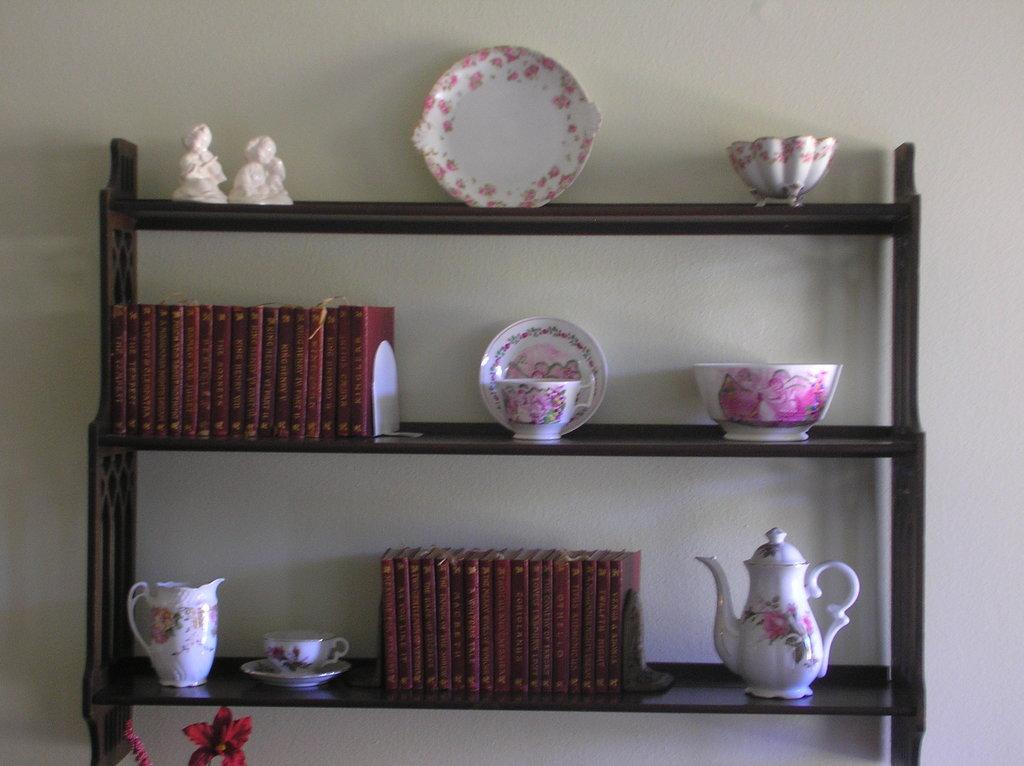What type of furniture is present in the image? There are shelves in the image. What items can be seen on the shelves? The shelves contain objects such as plates, bowls, jars, books, and mini statues. What is visible behind the shelves in the image? There is a wall visible in the image. Is there a cake on the shelves in the image? There is no cake present on the shelves in the image. Can you see an apple on the shelves in the image? There is no apple present on the shelves in the image. 